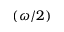Convert formula to latex. <formula><loc_0><loc_0><loc_500><loc_500>( \omega / 2 )</formula> 